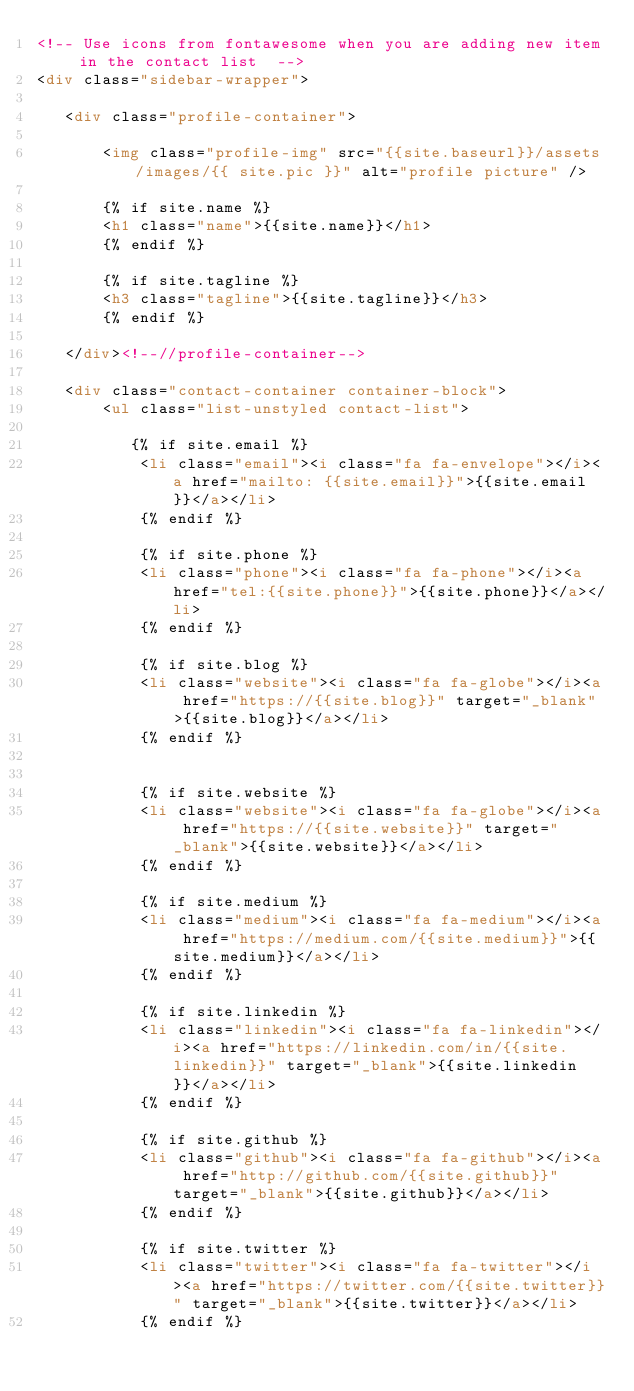<code> <loc_0><loc_0><loc_500><loc_500><_HTML_><!-- Use icons from fontawesome when you are adding new item in the contact list  -->
<div class="sidebar-wrapper">

   <div class="profile-container">

       <img class="profile-img" src="{{site.baseurl}}/assets/images/{{ site.pic }}" alt="profile picture" />

       {% if site.name %}
       <h1 class="name">{{site.name}}</h1>
       {% endif %}

       {% if site.tagline %}
       <h3 class="tagline">{{site.tagline}}</h3>
       {% endif %}

   </div><!--//profile-container-->

   <div class="contact-container container-block">
       <ul class="list-unstyled contact-list">

          {% if site.email %}
           <li class="email"><i class="fa fa-envelope"></i><a href="mailto: {{site.email}}">{{site.email}}</a></li>
           {% endif %}

           {% if site.phone %}
           <li class="phone"><i class="fa fa-phone"></i><a href="tel:{{site.phone}}">{{site.phone}}</a></li>
           {% endif %}

           {% if site.blog %}
           <li class="website"><i class="fa fa-globe"></i><a href="https://{{site.blog}}" target="_blank">{{site.blog}}</a></li>
           {% endif %}


           {% if site.website %}
           <li class="website"><i class="fa fa-globe"></i><a href="https://{{site.website}}" target="_blank">{{site.website}}</a></li>
           {% endif %}
           
           {% if site.medium %}
           <li class="medium"><i class="fa fa-medium"></i><a href="https://medium.com/{{site.medium}}">{{site.medium}}</a></li>
           {% endif %}

           {% if site.linkedin %}
           <li class="linkedin"><i class="fa fa-linkedin"></i><a href="https://linkedin.com/in/{{site.linkedin}}" target="_blank">{{site.linkedin}}</a></li>
           {% endif %}

           {% if site.github %}
           <li class="github"><i class="fa fa-github"></i><a href="http://github.com/{{site.github}}" target="_blank">{{site.github}}</a></li>
           {% endif %}

           {% if site.twitter %}
           <li class="twitter"><i class="fa fa-twitter"></i><a href="https://twitter.com/{{site.twitter}}" target="_blank">{{site.twitter}}</a></li>
           {% endif %}
</code> 